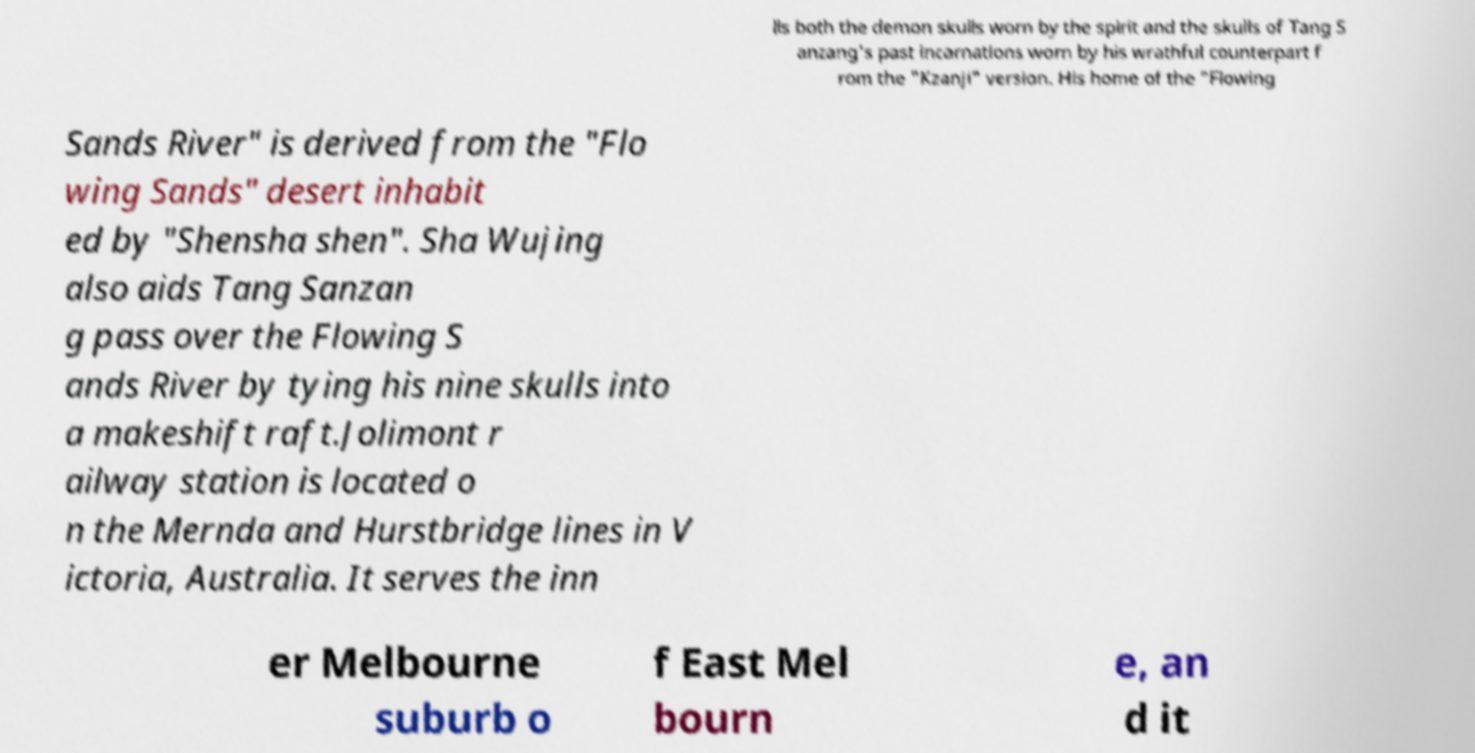Could you assist in decoding the text presented in this image and type it out clearly? lls both the demon skulls worn by the spirit and the skulls of Tang S anzang's past incarnations worn by his wrathful counterpart f rom the "Kzanji" version. His home of the "Flowing Sands River" is derived from the "Flo wing Sands" desert inhabit ed by "Shensha shen". Sha Wujing also aids Tang Sanzan g pass over the Flowing S ands River by tying his nine skulls into a makeshift raft.Jolimont r ailway station is located o n the Mernda and Hurstbridge lines in V ictoria, Australia. It serves the inn er Melbourne suburb o f East Mel bourn e, an d it 